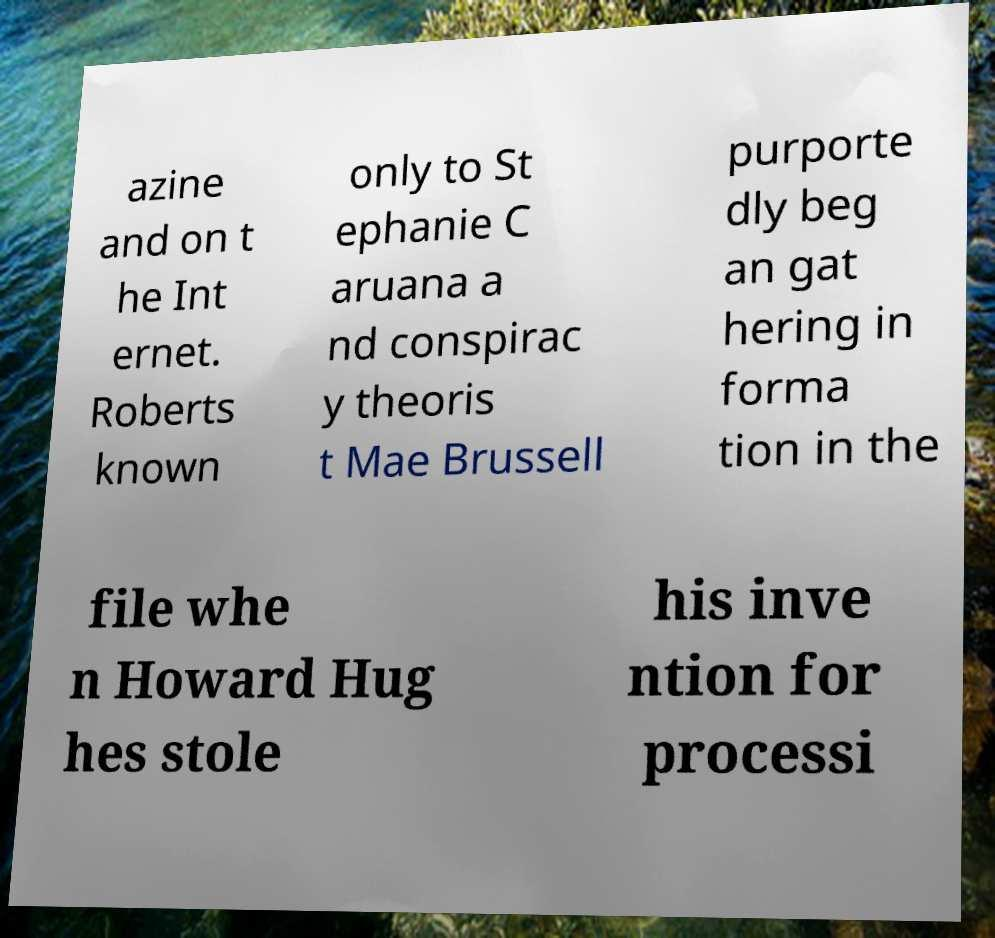Can you accurately transcribe the text from the provided image for me? azine and on t he Int ernet. Roberts known only to St ephanie C aruana a nd conspirac y theoris t Mae Brussell purporte dly beg an gat hering in forma tion in the file whe n Howard Hug hes stole his inve ntion for processi 